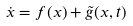Convert formula to latex. <formula><loc_0><loc_0><loc_500><loc_500>\dot { x } = f ( x ) + \tilde { g } ( x , t )</formula> 